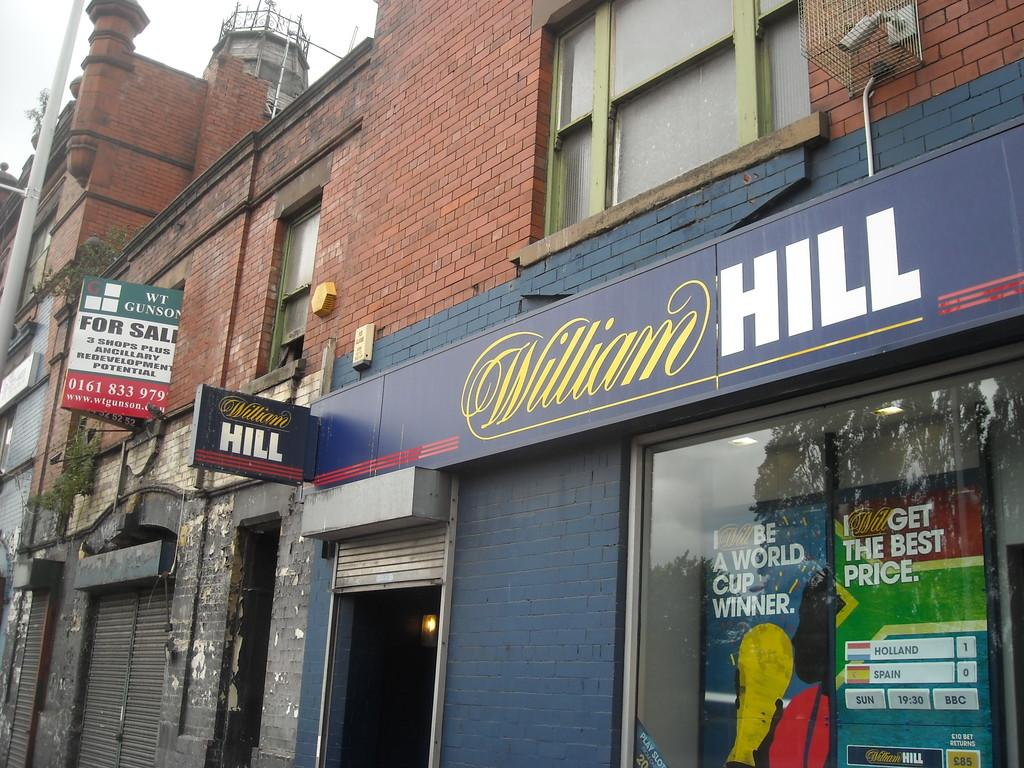What type of structure is present in the image? There is a building in the image. What can be found inside the building? There are shops in the image. What is the large sign in the image called? There is a hoarding in the image. What information is displayed on the hoarding? There are words visible on the hoarding. What is the tall, thin object in the image? There is a pole in the image. What part of the natural environment is visible in the image? The sky is visible in the image. What is the rate of the camera's shutter speed in the image? There is no camera present in the image, so it is not possible to determine the shutter speed. 